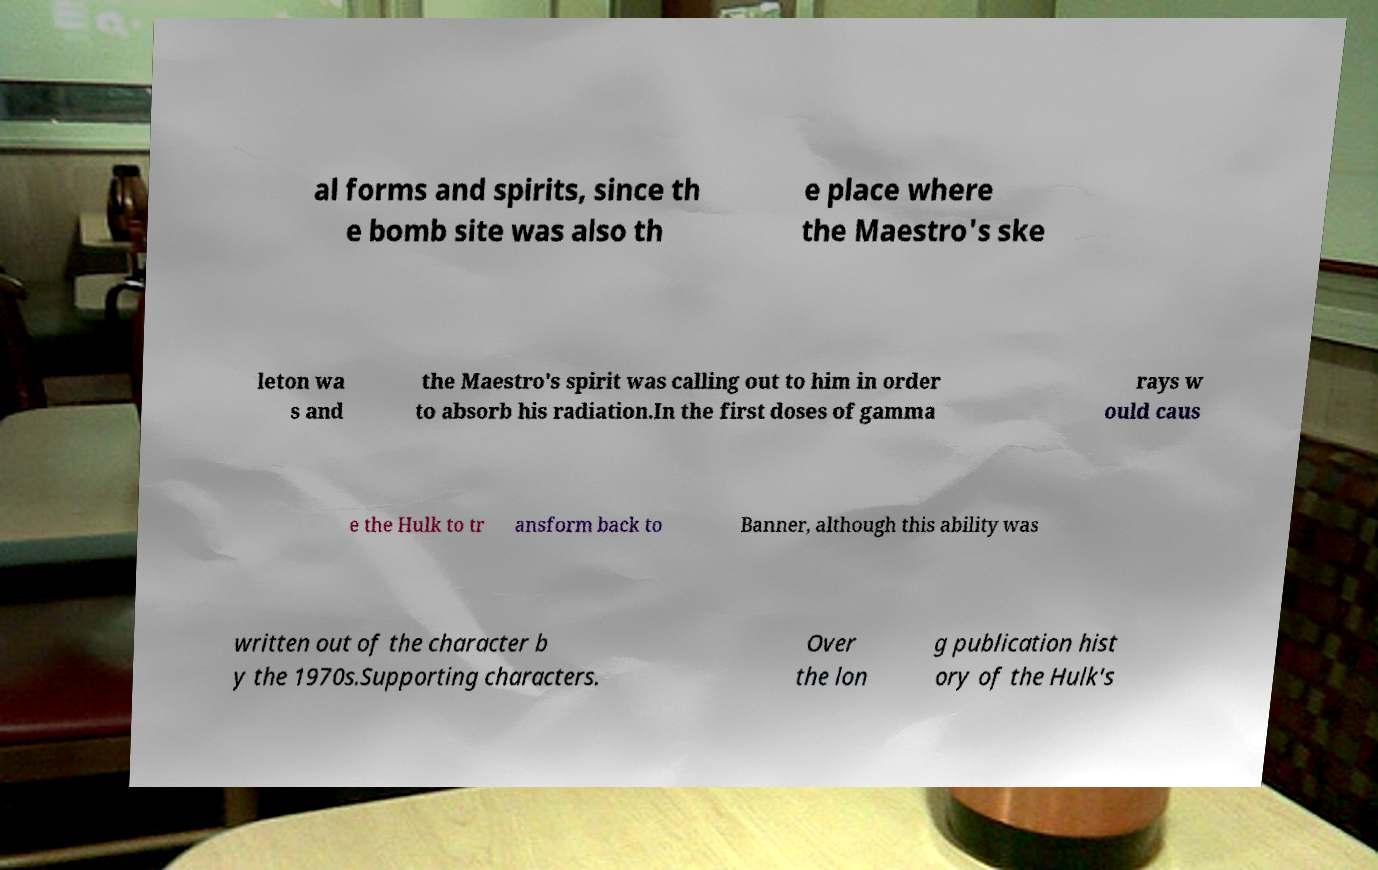Could you assist in decoding the text presented in this image and type it out clearly? al forms and spirits, since th e bomb site was also th e place where the Maestro's ske leton wa s and the Maestro's spirit was calling out to him in order to absorb his radiation.In the first doses of gamma rays w ould caus e the Hulk to tr ansform back to Banner, although this ability was written out of the character b y the 1970s.Supporting characters. Over the lon g publication hist ory of the Hulk's 